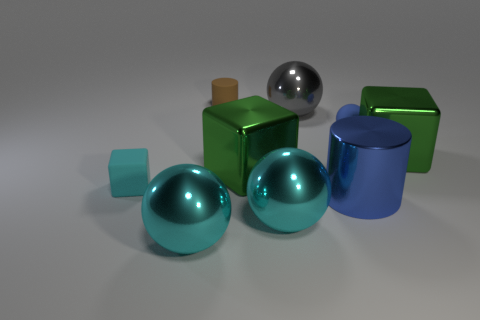Is the number of cyan spheres that are on the left side of the cyan matte object greater than the number of big shiny spheres?
Offer a terse response. No. Is the matte cylinder the same color as the large cylinder?
Keep it short and to the point. No. How many big gray objects have the same shape as the small brown object?
Ensure brevity in your answer.  0. What is the size of the sphere that is the same material as the brown thing?
Give a very brief answer. Small. There is a big ball that is right of the brown cylinder and in front of the tiny blue matte object; what color is it?
Your answer should be compact. Cyan. How many green shiny objects have the same size as the metallic cylinder?
Your response must be concise. 2. What is the size of the sphere that is the same color as the metal cylinder?
Your answer should be very brief. Small. There is a cyan object that is both in front of the tiny cyan object and left of the tiny cylinder; what is its size?
Your response must be concise. Large. There is a big metallic block on the left side of the green thing that is to the right of the gray sphere; how many small spheres are to the left of it?
Your answer should be compact. 0. Are there any large shiny cylinders that have the same color as the small matte cylinder?
Your answer should be compact. No. 